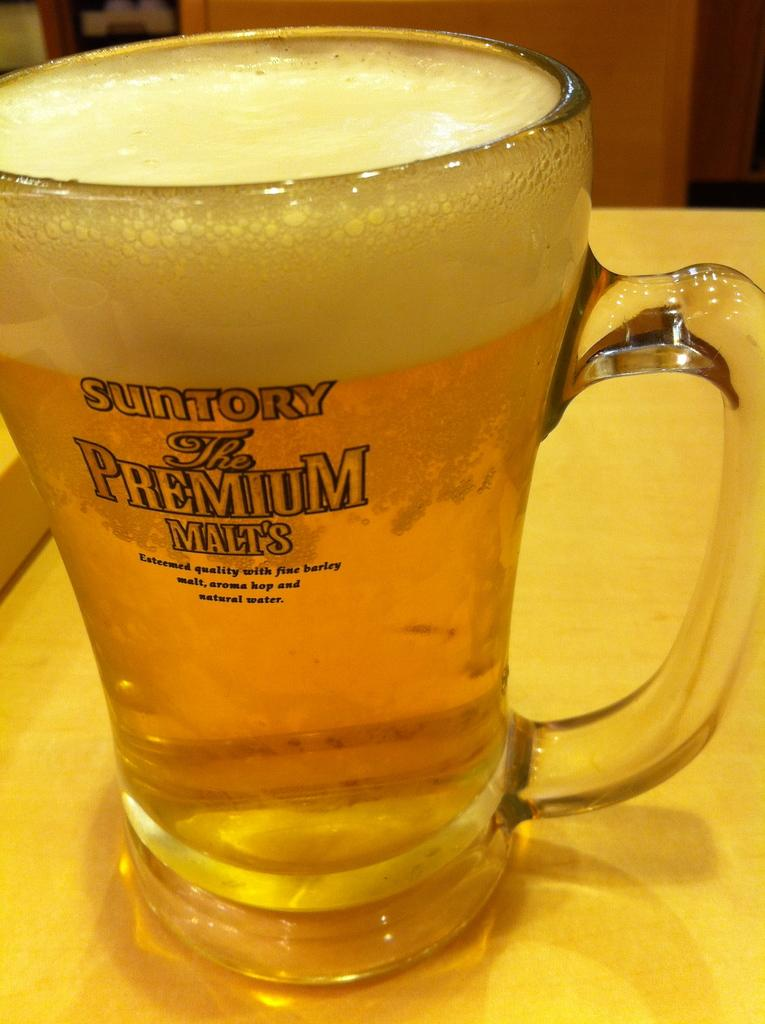What object is present in the image that is typically used for holding liquids? There is a glass in the image. What type of liquid is contained within the glass? The glass contains beer. Where is the glass located in the image? The glass is on a table. How much money is being exchanged between the woman and the man in the image? There is no woman or man present in the image, and therefore no exchange of money can be observed. 